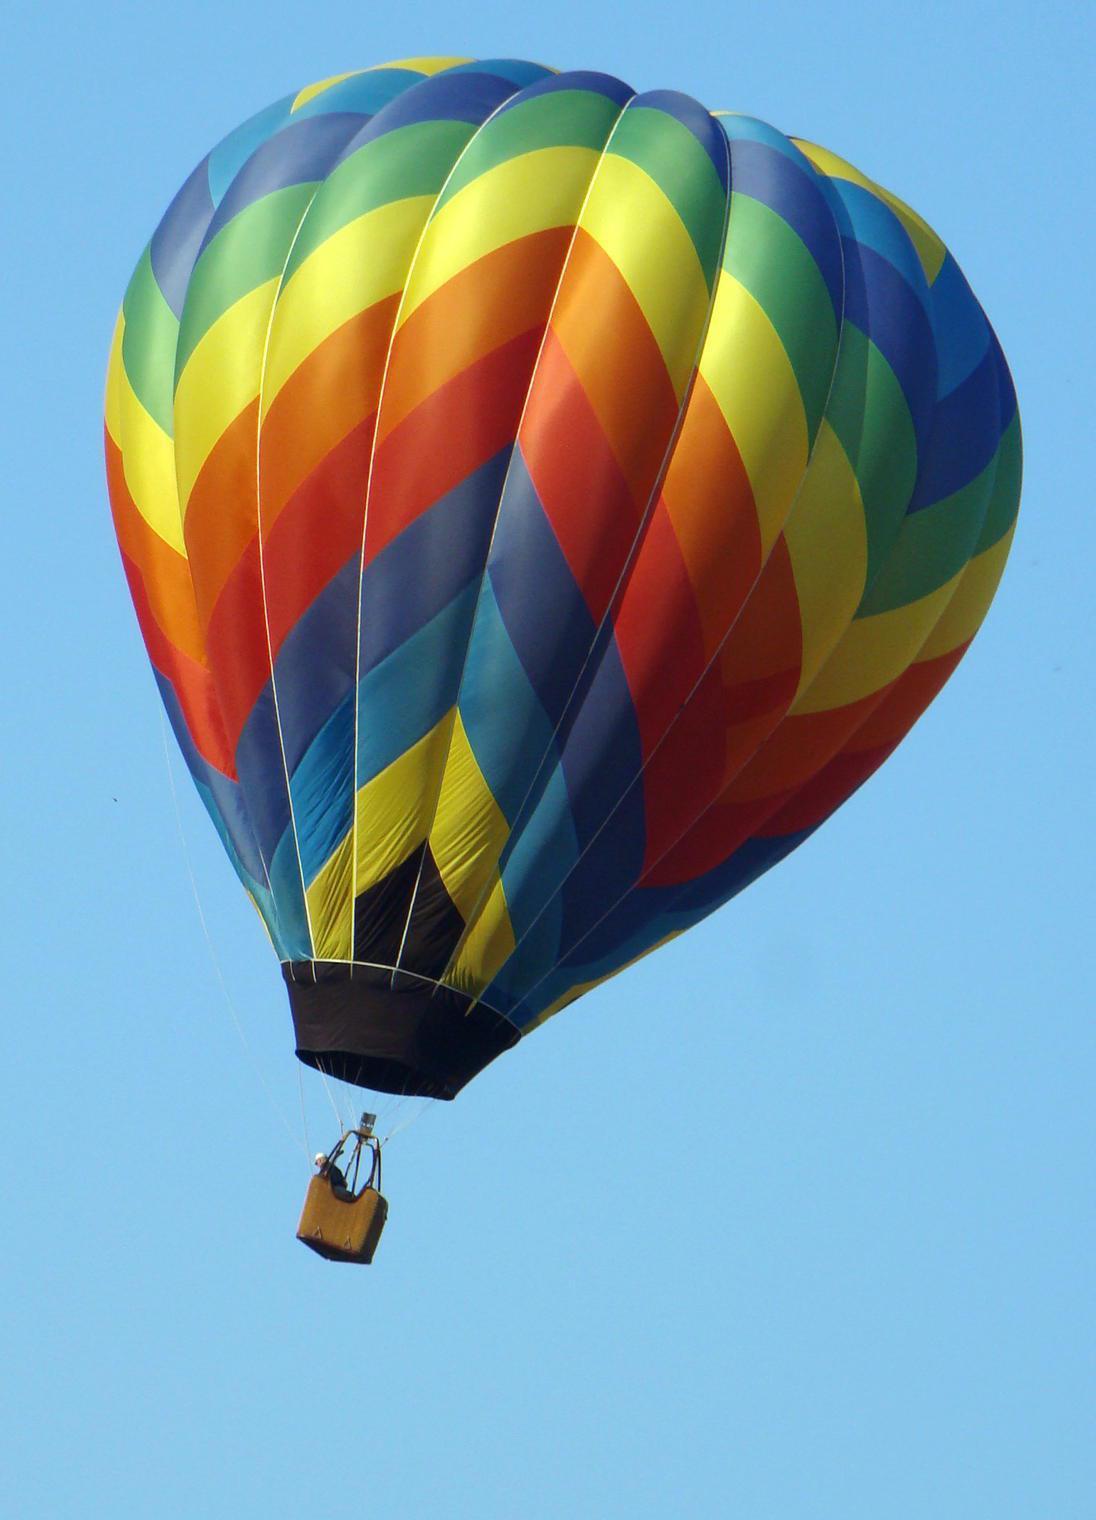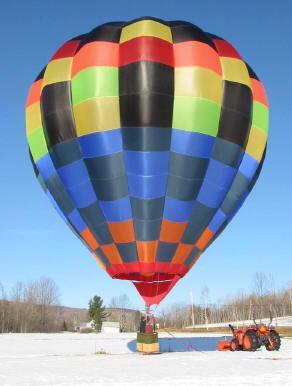The first image is the image on the left, the second image is the image on the right. For the images displayed, is the sentence "In total, two hot-air balloons are shown, each floating in the air." factually correct? Answer yes or no. No. 